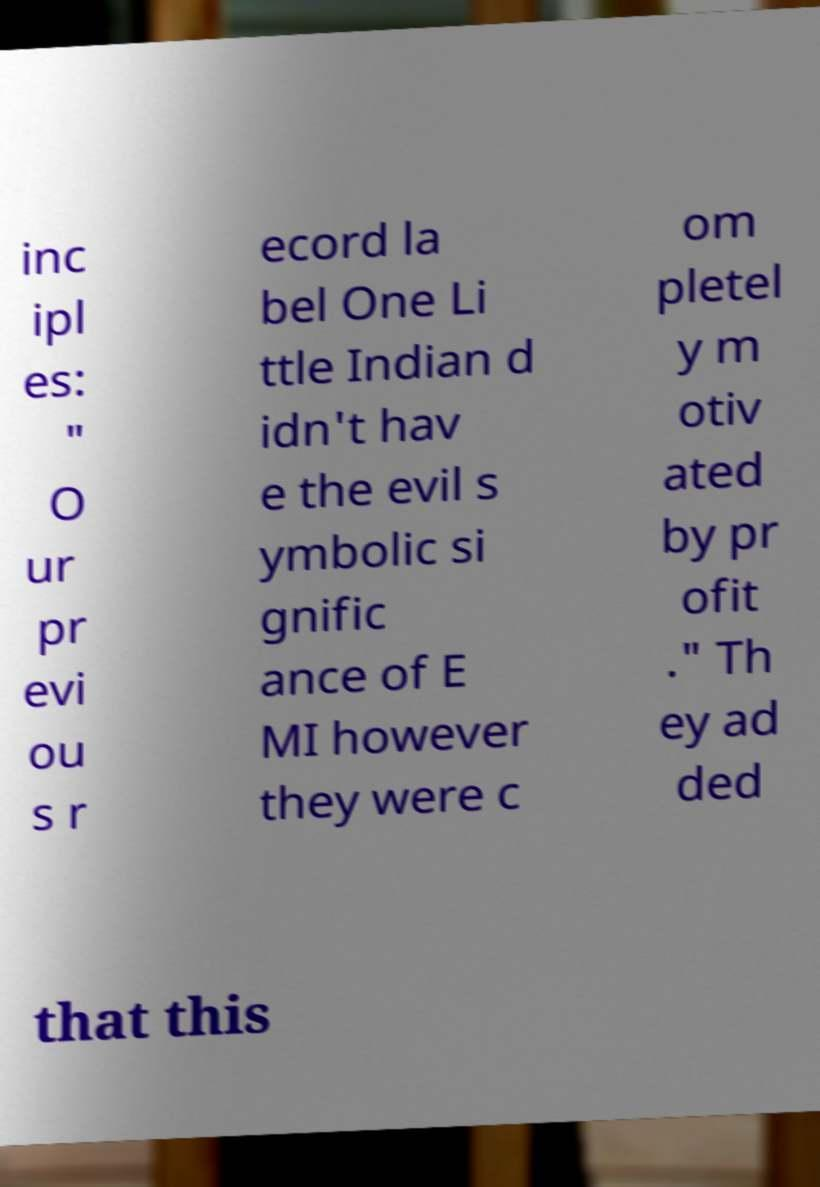Can you read and provide the text displayed in the image?This photo seems to have some interesting text. Can you extract and type it out for me? inc ipl es: " O ur pr evi ou s r ecord la bel One Li ttle Indian d idn't hav e the evil s ymbolic si gnific ance of E MI however they were c om pletel y m otiv ated by pr ofit ." Th ey ad ded that this 